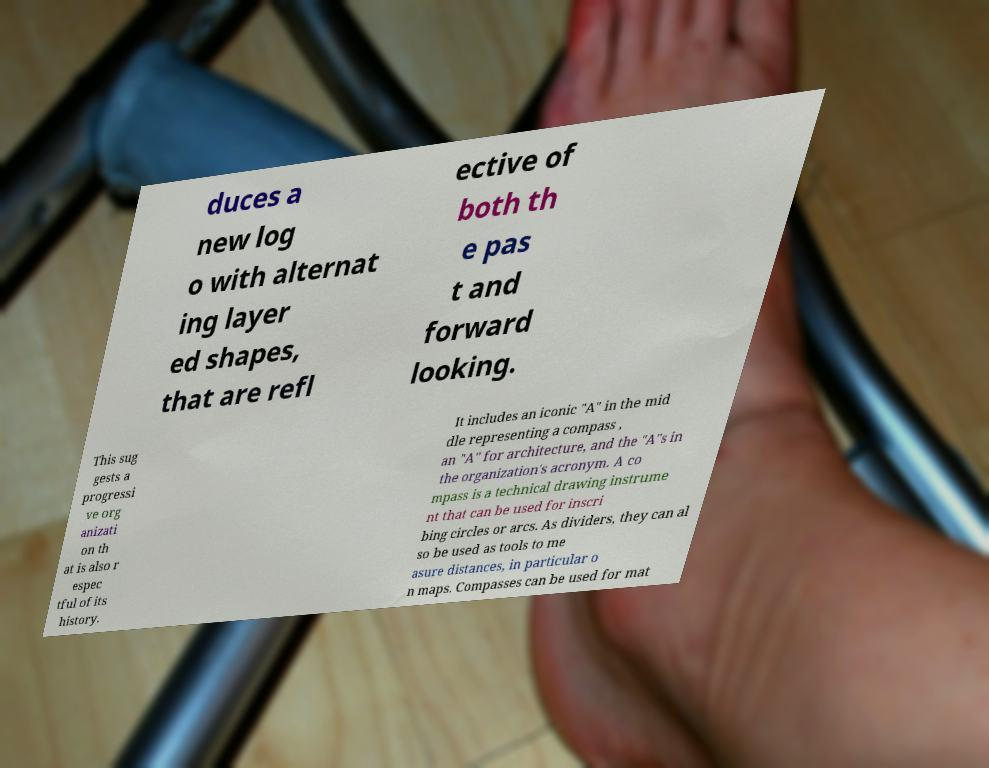Please identify and transcribe the text found in this image. duces a new log o with alternat ing layer ed shapes, that are refl ective of both th e pas t and forward looking. This sug gests a progressi ve org anizati on th at is also r espec tful of its history. It includes an iconic "A" in the mid dle representing a compass , an "A" for architecture, and the "A"s in the organization's acronym. A co mpass is a technical drawing instrume nt that can be used for inscri bing circles or arcs. As dividers, they can al so be used as tools to me asure distances, in particular o n maps. Compasses can be used for mat 